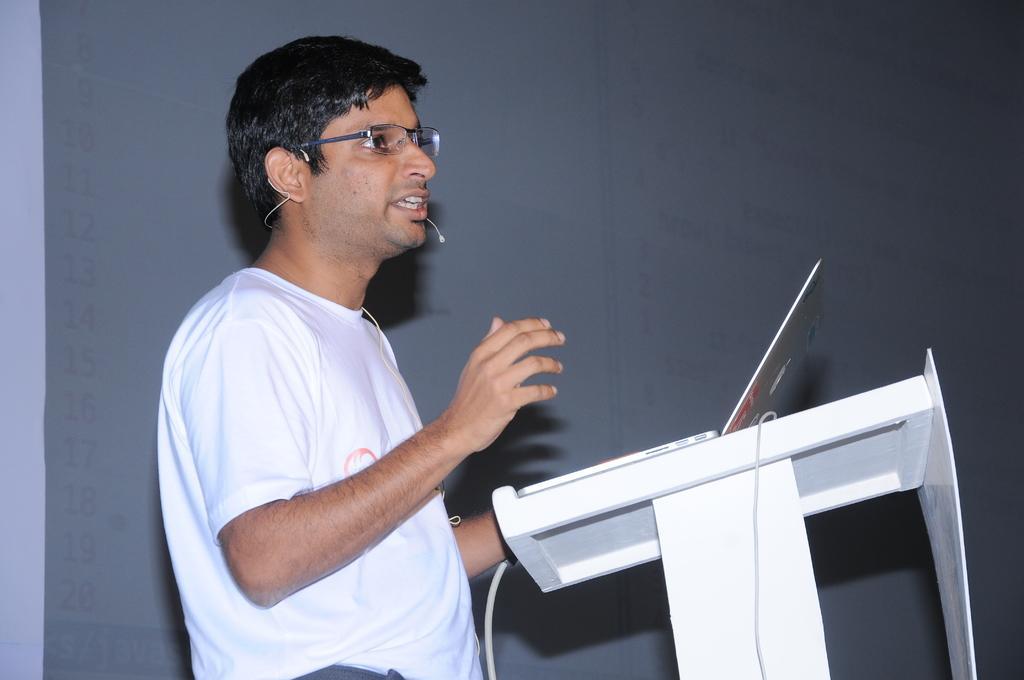Please provide a concise description of this image. In this image there is a man who is wearing the white t-shirt is speaking in the mic. In front of him there is a podium on which there is a laptop. In the background there is a wall. 